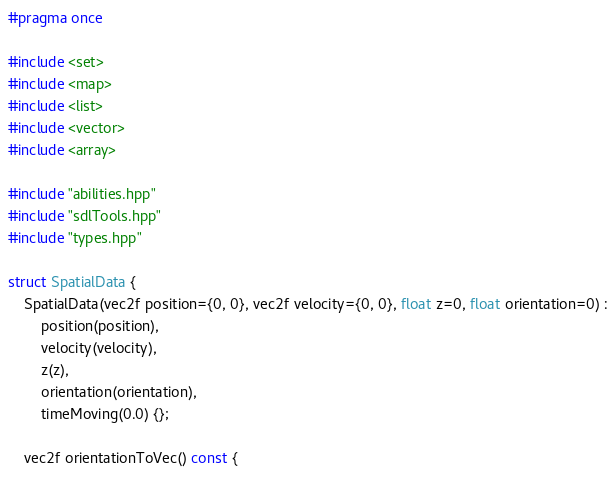<code> <loc_0><loc_0><loc_500><loc_500><_C++_>#pragma once

#include <set>
#include <map>
#include <list>
#include <vector>
#include <array>

#include "abilities.hpp"
#include "sdlTools.hpp"
#include "types.hpp"

struct SpatialData {
	SpatialData(vec2f position={0, 0}, vec2f velocity={0, 0}, float z=0, float orientation=0) :
		position(position),
		velocity(velocity),
		z(z),
		orientation(orientation),
		timeMoving(0.0) {};

	vec2f orientationToVec() const {</code> 